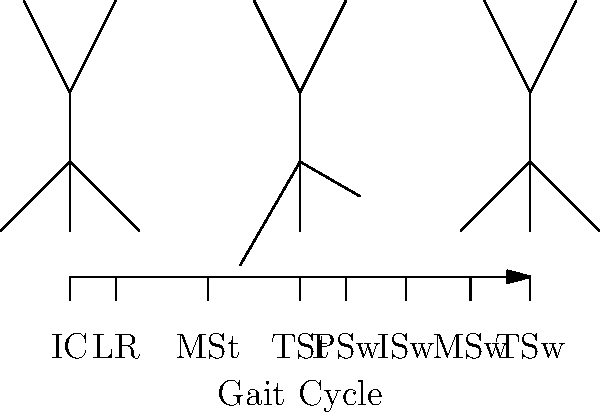Analyze the gait cycle diagram above, which uses stick figures to represent key phases. Which phase of the gait cycle is represented by the middle stick figure, and what percentage of the cycle does it occur at? To answer this question, let's analyze the gait cycle diagram step-by-step:

1. The diagram shows a timeline of the gait cycle from 0% to 100%.
2. There are 8 labeled phases: IC (Initial Contact), LR (Loading Response), MSt (Mid Stance), TSt (Terminal Stance), PSw (Pre-Swing), ISw (Initial Swing), MSw (Mid Swing), and TSw (Terminal Swing).
3. Three stick figures are shown at different points in the cycle:
   - The first figure is at 0% (Initial Contact)
   - The middle figure is at 50%
   - The last figure is at 100% (completing the cycle)
4. The middle stick figure, which we're asked about, is positioned at the 50% mark of the gait cycle.
5. Looking at the labels below the timeline, we can see that the 50% mark corresponds to the end of the TSt (Terminal Stance) phase.
6. The TSt phase begins at 30% and ends at 50% of the gait cycle.

Therefore, the middle stick figure represents the Terminal Stance (TSt) phase, occurring at 50% of the gait cycle.
Answer: Terminal Stance (TSt), 50% 